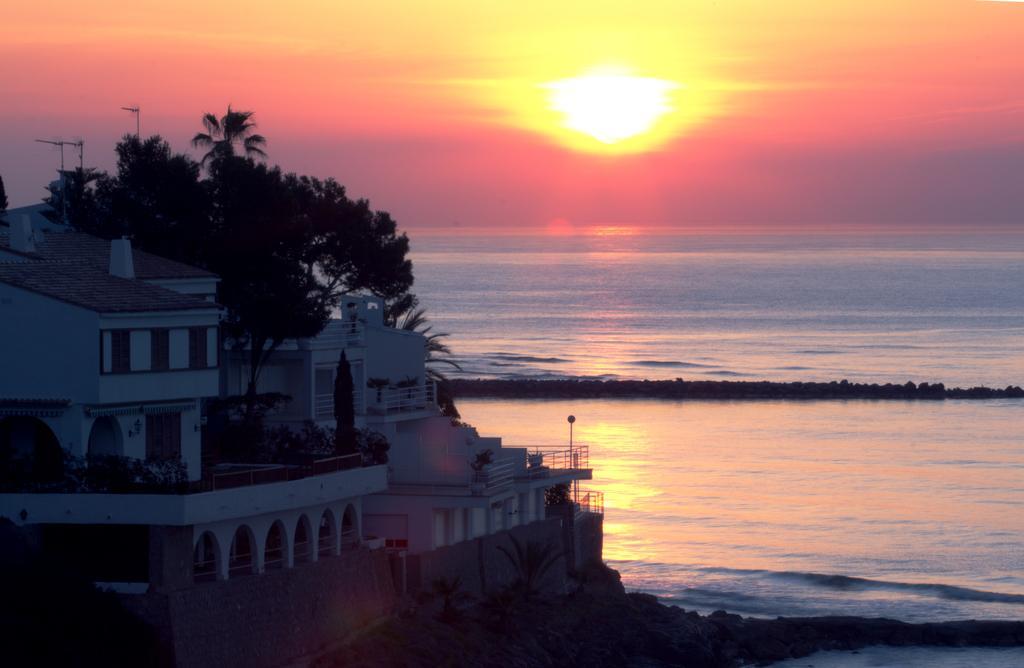Could you give a brief overview of what you see in this image? There is a beautiful house and in front of the house there is a sea and there is a pleasant view of sun rise in front of the sea. 